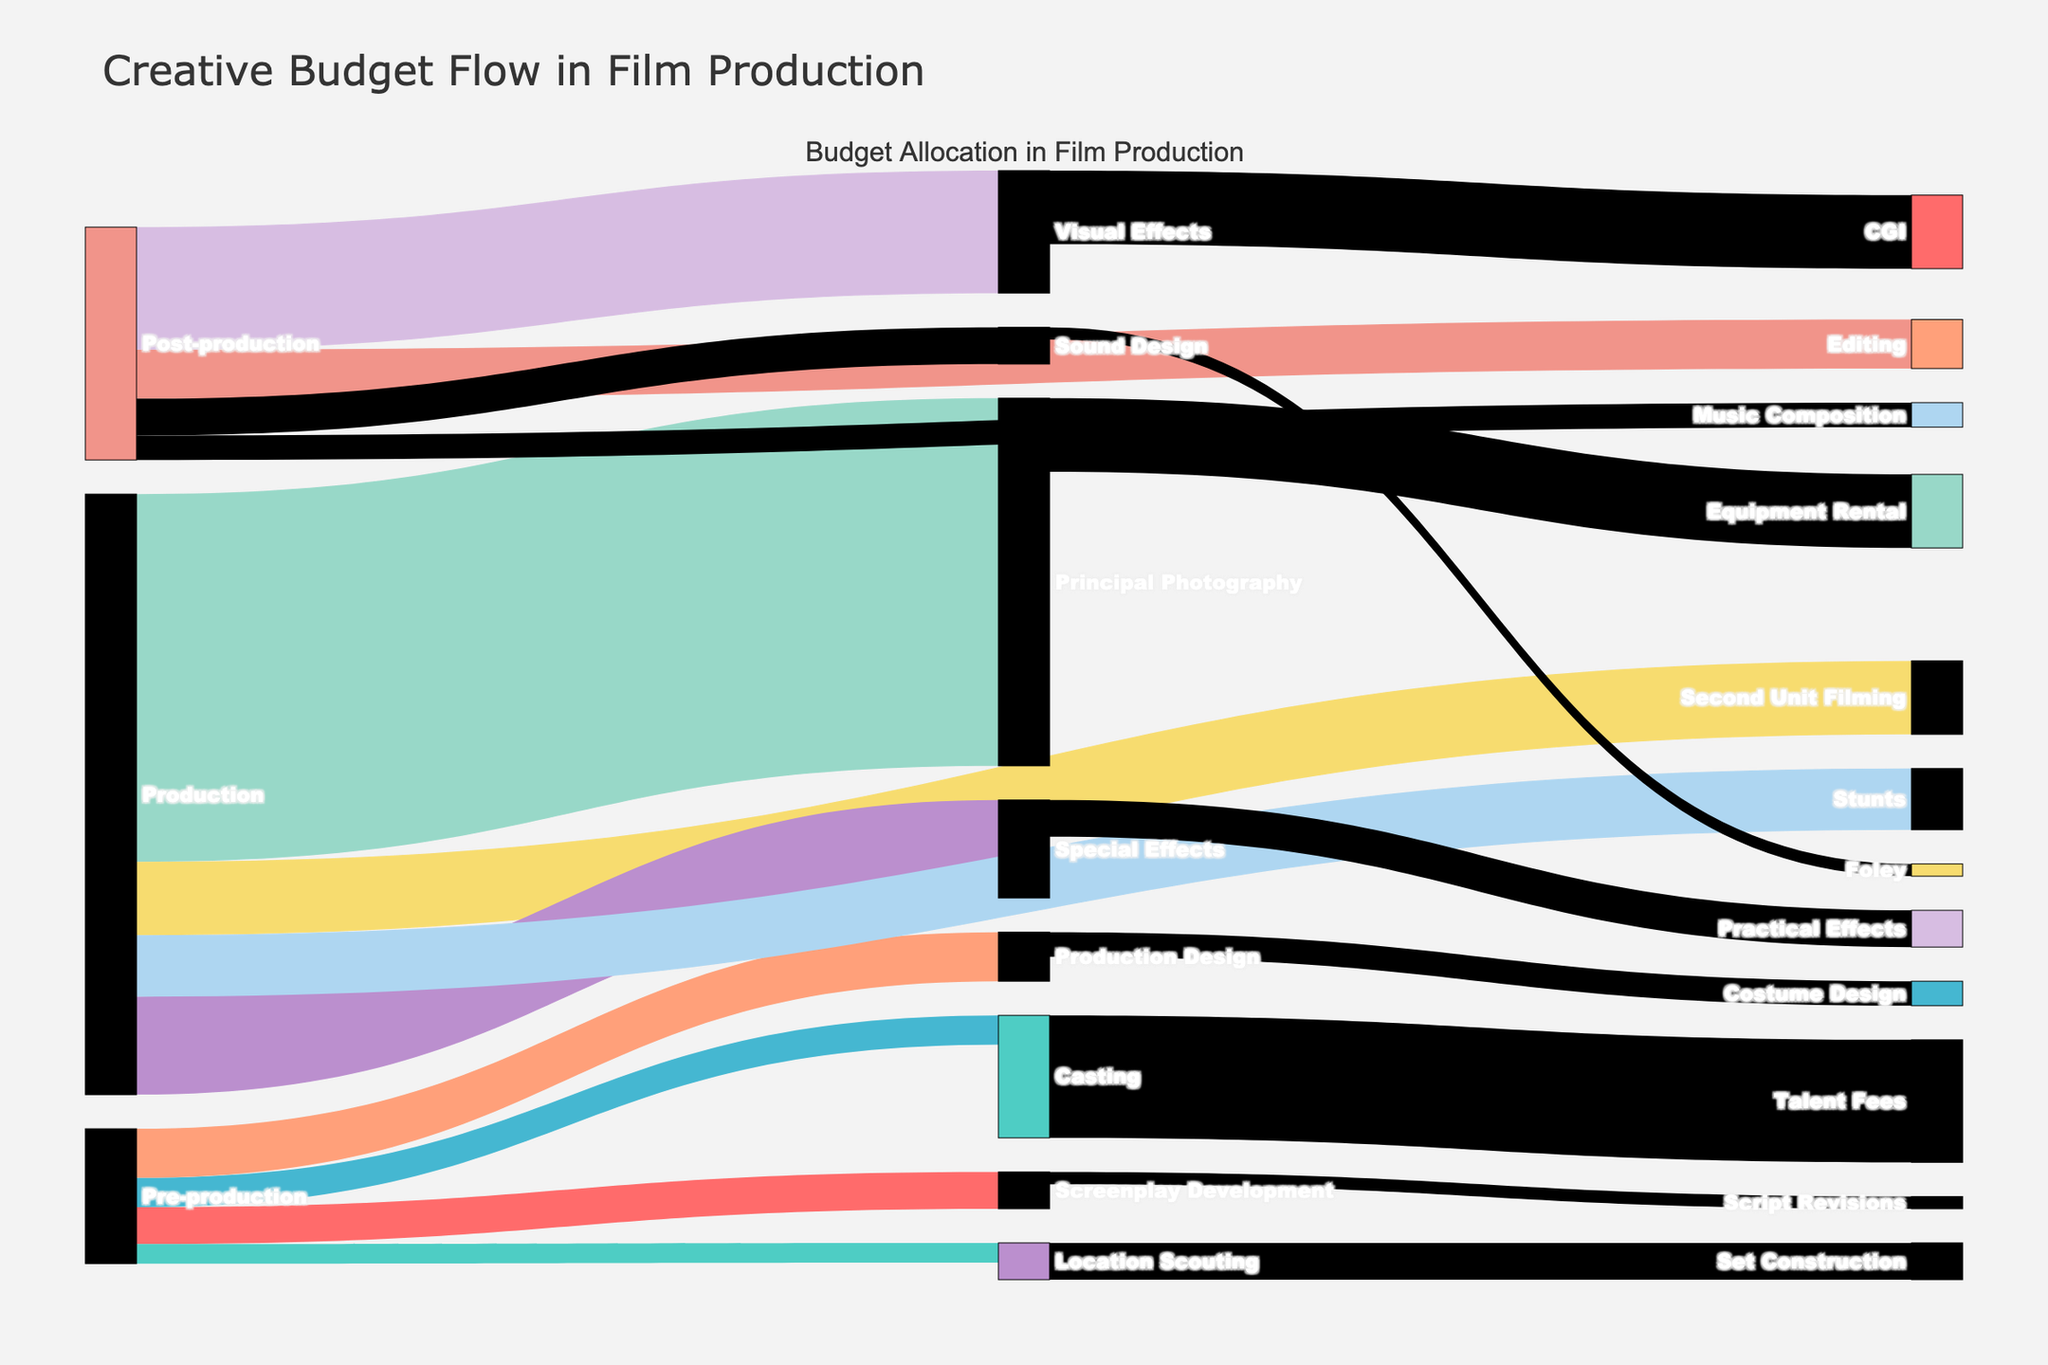What is the total budget allocated to Pre-production? Sum up the values distributed to all targets of Pre-production: 150000 (Screenplay Development) + 80000 (Location Scouting) + 120000 (Casting) + 200000 (Production Design) = 550000.
Answer: 550000 Which stage of Post-production has the highest budget allocation? Compare the budgets for Editing (200000), Visual Effects (500000), Sound Design (150000), and Music Composition (100000). Visual Effects has the highest value.
Answer: Visual Effects How much budget is allocated to both Principal Photography and Equipment Rental together? Sum the amounts for Principal Photography (1500000) and Equipment Rental (300000): 1500000 + 300000 = 1800000.
Answer: 1800000 Among Casting and Production Design, which has a higher value associated with it? Compare the values: Casting (120000) vs. Production Design (200000). Production Design is higher.
Answer: Production Design What is the budget difference between Stunts in Production and Sound Design in Post-production? Subtract the budget for Sound Design (150000) from the budget for Stunts (250000): 250000 - 150000 = 100000.
Answer: 100000 How does the budget allocation for Special Effects compare to that for Visual Effects? Compare the values: Special Effects has 400000 while Visual Effects has 500000. Visual Effects has a higher budget.
Answer: Visual Effects What are the total budgets allocated to the stages of Production and Post-production combined? Sum the budgets for Production (1500000 + 300000 + 400000 + 250000 = 2450000) and Post-production (200000 + 500000 + 150000 + 100000 = 950000): 2450000 + 950000 = 3400000.
Answer: 3400000 Which task in Pre-production has the lowest budget allocation? Compare the budgets of all Pre-production tasks: Screenplay Development (150000), Location Scouting (80000), Casting (120000), Production Design (200000). Location Scouting has the lowest value.
Answer: Location Scouting What is the combined budget for any tasks directly linked to Visual Effects? Add up the budgets of tasks linked to Visual Effects: 500000 (Post-production) and 300000 (CGI) = 800000.
Answer: 800000 